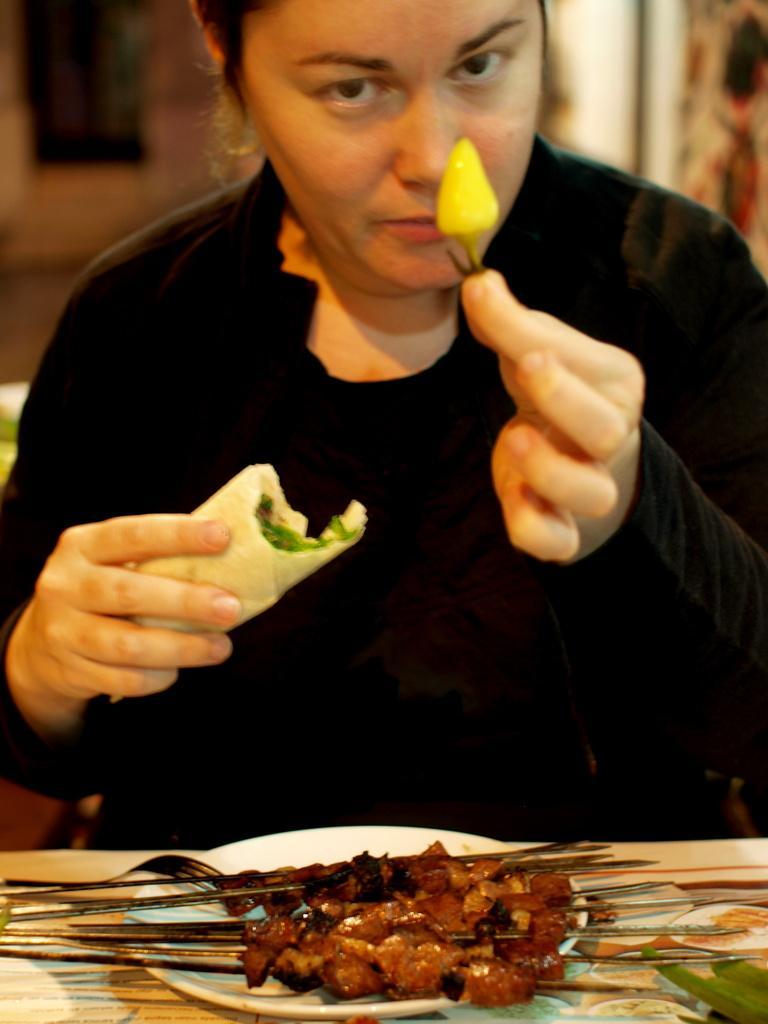Could you give a brief overview of what you see in this image? The woman in the middle of the picture wearing a black T-shirt and black jacket is sitting on the chair. She is holding a yellow chili in one of her hands and in the other hand, she is holding an edible. In front of her, we see a table on which plate containing food are placed. 